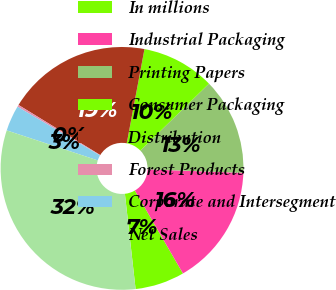<chart> <loc_0><loc_0><loc_500><loc_500><pie_chart><fcel>In millions<fcel>Industrial Packaging<fcel>Printing Papers<fcel>Consumer Packaging<fcel>Distribution<fcel>Forest Products<fcel>Corporate and Intersegment<fcel>Net Sales<nl><fcel>6.58%<fcel>16.05%<fcel>12.89%<fcel>9.74%<fcel>19.21%<fcel>0.26%<fcel>3.42%<fcel>31.85%<nl></chart> 